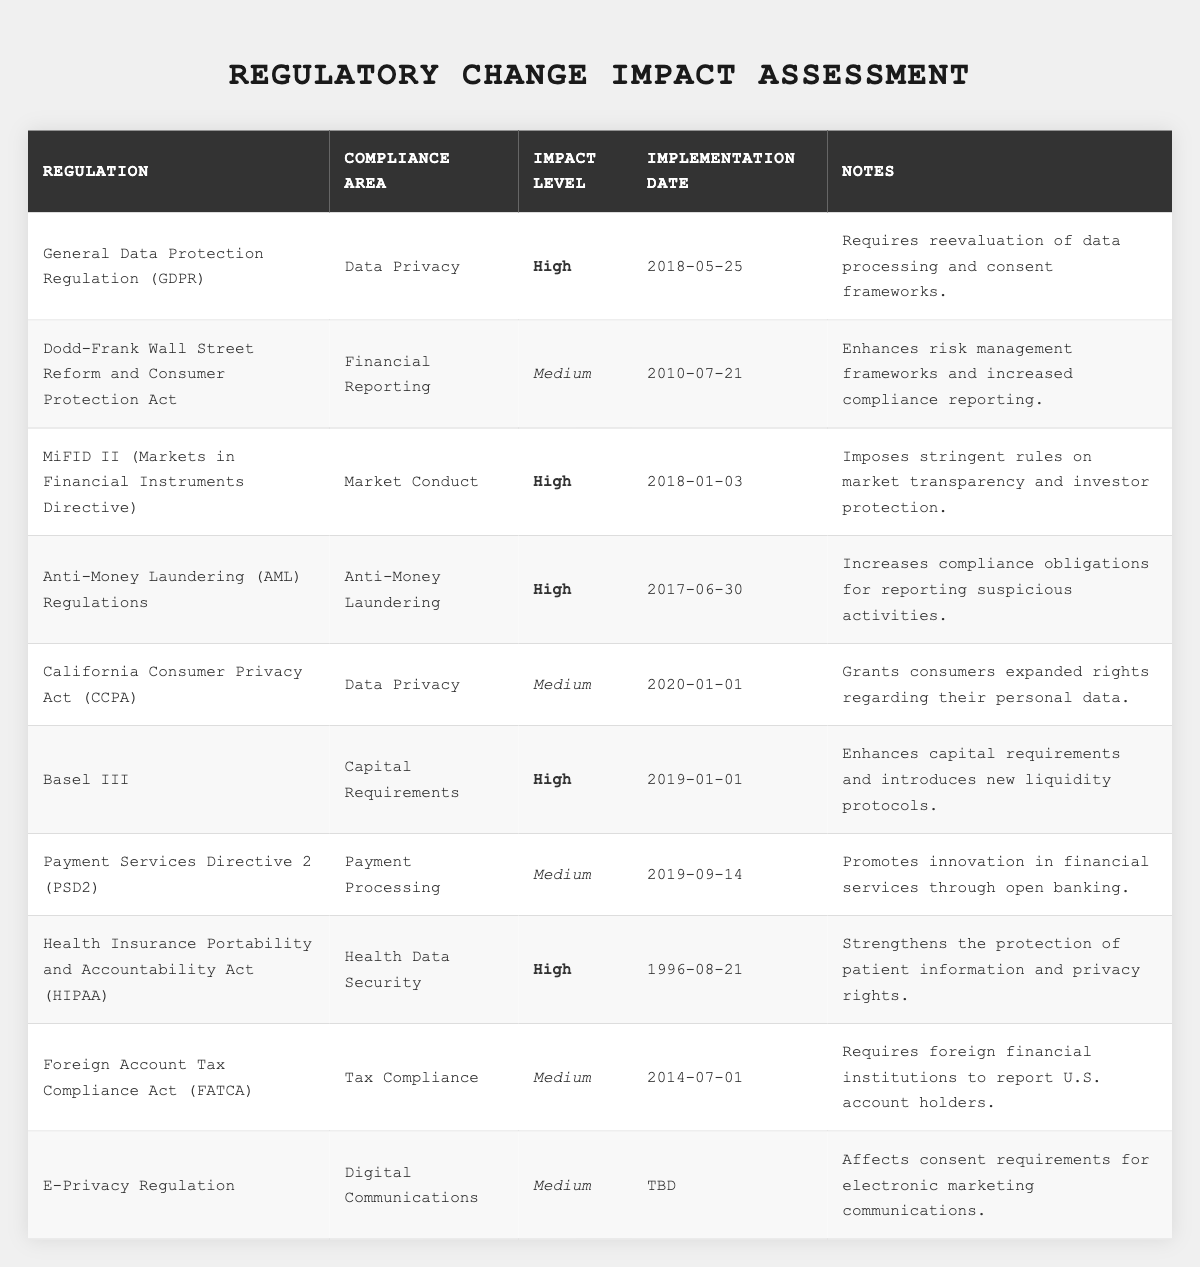What is the impact level of the GDPR? The table lists the General Data Protection Regulation (GDPR) under the "Impact Level" column, which shows that the impact level is "High."
Answer: High Which compliance area does MiFID II relate to? In the table, MiFID II is categorized under the "Compliance Area" column, indicating it relates to "Market Conduct."
Answer: Market Conduct How many regulations have a high impact level? By reviewing the table, there are 5 regulations that have a high impact level (GDPR, MiFID II, AML Regulations, Basel III, HIPAA).
Answer: 5 What was the implementation date of the CCPA? The "Implementation Date" column shows that the California Consumer Privacy Act (CCPA) was implemented on "2020-01-01."
Answer: 2020-01-01 Is the impact level of the E-Privacy Regulation high? The E-Privacy Regulation is listed as having a "Medium" impact level, indicating it is not high.
Answer: No What is the difference in impact level between GDPR and CCPA? The GDPR has a "High" impact level, while the CCPA has a "Medium" impact level. Therefore, the difference is that GDPR is one level higher than CCPA.
Answer: High Which compliance area has the most regulations listed? By examining the table, both "Data Privacy" and "Medium" impact level each have 2 instances (GDPR and CCPA), while other areas have fewer distinct regulations. However, there is a tie between the two.
Answer: Data Privacy, Market Conduct, and others tied What is the average impact level of the listed regulations based on the count of high (3), medium (5), and low (none)? To find the average, we convert "High" to 3, "Medium" to 2. Total score = (3*5 + 2*5) / 10 = 2.5. We categorize the outcome as between medium and high.
Answer: Between Medium and High Which regulation requires reevaluation of data processing practices? The table notes that the GDPR requires reevaluation of data processing and consent frameworks based on its corresponding entry in the "Notes" column.
Answer: GDPR What is the relationship between Basel III and capital requirements? The table explicitly states that Basel III is in the "Capital Requirements" compliance area, indicating a direct relationship focused on enhancing capital requirements.
Answer: Enhances capital requirements 